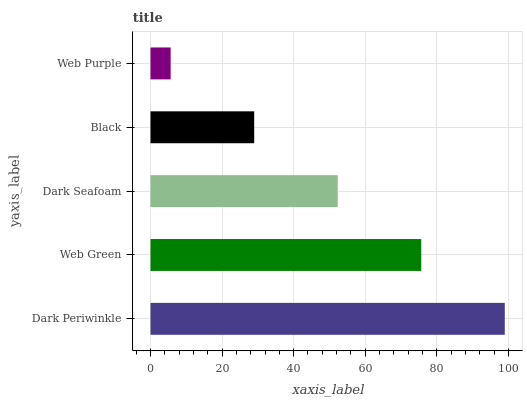Is Web Purple the minimum?
Answer yes or no. Yes. Is Dark Periwinkle the maximum?
Answer yes or no. Yes. Is Web Green the minimum?
Answer yes or no. No. Is Web Green the maximum?
Answer yes or no. No. Is Dark Periwinkle greater than Web Green?
Answer yes or no. Yes. Is Web Green less than Dark Periwinkle?
Answer yes or no. Yes. Is Web Green greater than Dark Periwinkle?
Answer yes or no. No. Is Dark Periwinkle less than Web Green?
Answer yes or no. No. Is Dark Seafoam the high median?
Answer yes or no. Yes. Is Dark Seafoam the low median?
Answer yes or no. Yes. Is Black the high median?
Answer yes or no. No. Is Black the low median?
Answer yes or no. No. 